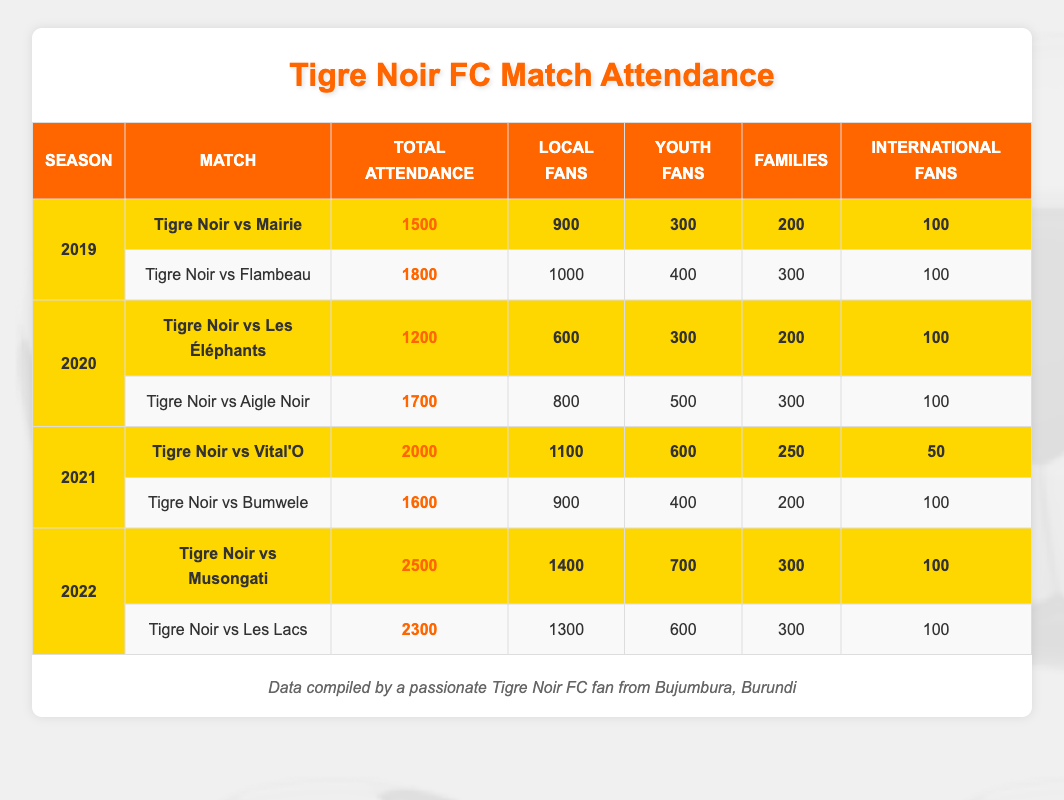What was the total attendance for Tigre Noir FC matches in 2021? To find the total attendance in 2021, I need to sum the total attendance for both matches that season, which are Tigre Noir vs Vital'O (2000) and Tigre Noir vs Bumwele (1600). Thus, 2000 + 1600 = 3600.
Answer: 3600 Which match had the highest attendance in 2022? The attendance for Tigre Noir vs Musongati is 2500, and for Tigre Noir vs Les Lacs it is 2300. Since 2500 is greater than 2300, the match with the highest attendance is Tigre Noir vs Musongati.
Answer: Tigre Noir vs Musongati Did Local Fans represent more than 50% of the total attendance for the match Tigre Noir vs Mairie in 2019? The total attendance for Tigre Noir vs Mairie is 1500, with Local Fans being 900. To check if this is more than 50%, I calculate 50% of 1500 (which is 750), and since 900 is greater than 750, Local Fans did indeed represent more than 50%.
Answer: Yes What is the average attendance for Tigre Noir matches across all seasons? To calculate the average, I first sum all the total attendance values: 1500 + 1800 + 1200 + 1700 + 2000 + 1600 + 2500 + 2300 = 14100. There are 8 matches in total, so I divide 14100 by 8, resulting in an average attendance of 1762.5.
Answer: 1762.5 How many more Local Fans attended the match against Musongati compared to the match against Vital'O in 2021? For the match against Musongati, Local Fans were 1400, and for the match against Vital'O, they were 1100. To find how many more attended the match against Musongati, I subtract 1100 from 1400. Thus, 1400 - 1100 = 300.
Answer: 300 